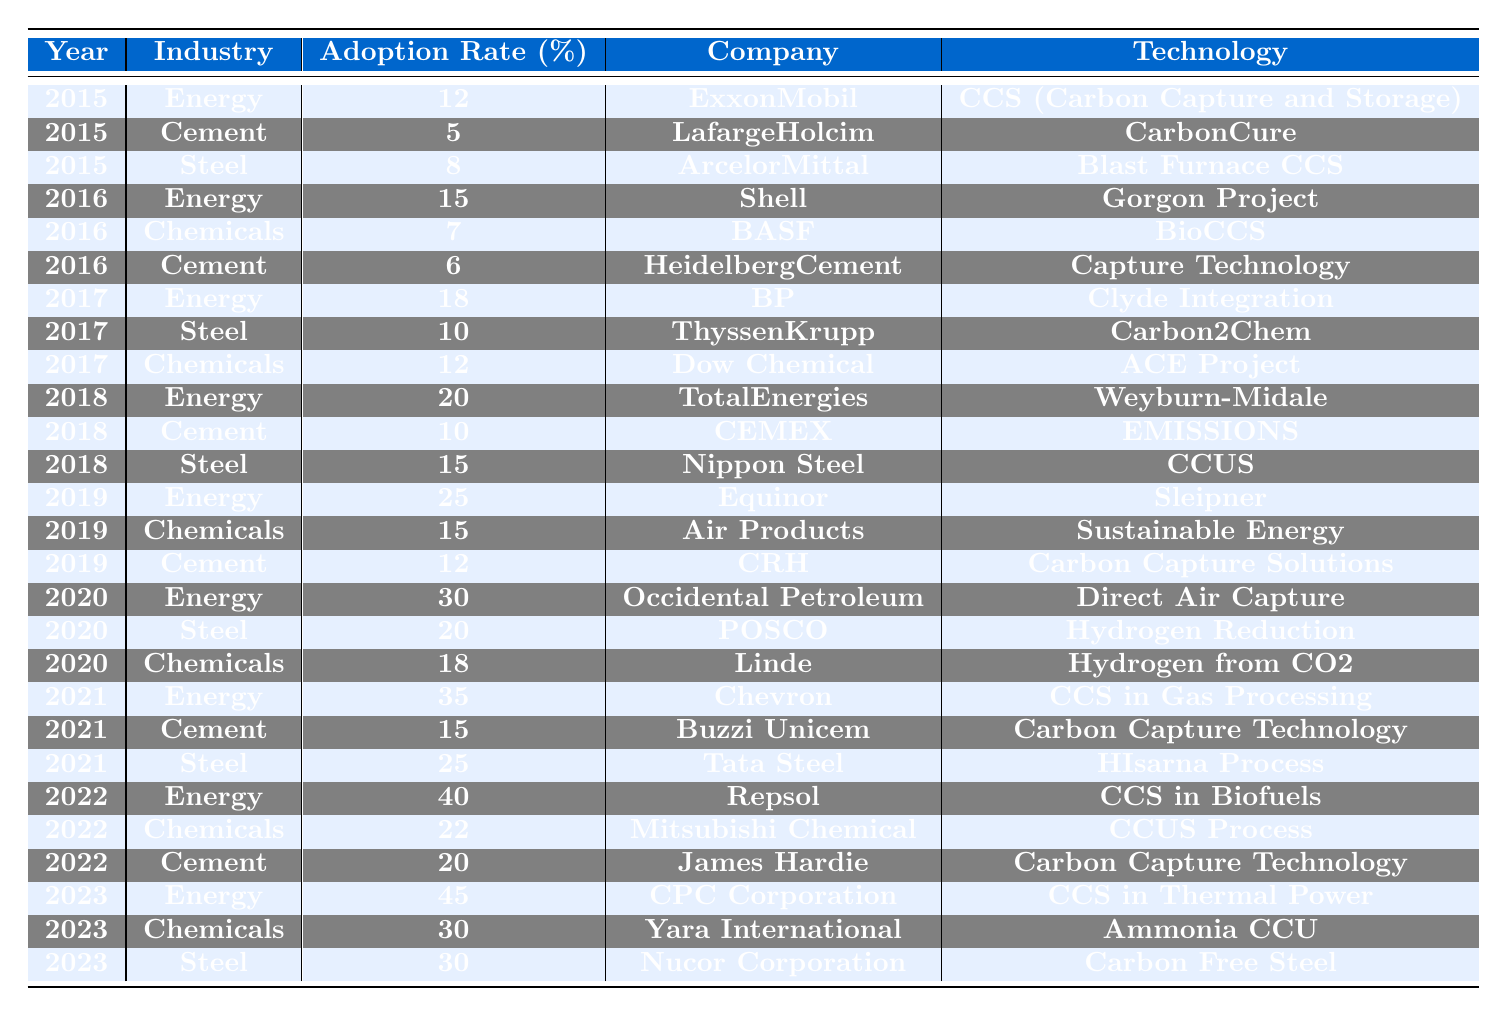What was the highest adoption rate in the Energy industry? The highest adoption rate in the Energy industry is found in 2023 with a rate of 45%.
Answer: 45% Which technology was used by BP in the Energy sector in 2017? BP used the "Clyde Integration" technology in the Energy sector in 2017.
Answer: Clyde Integration What is the difference in adoption rates between Steel in 2015 and in 2023? In 2015, the Steel adoption rate was 8%, while in 2023 it was 30%. The difference is 30% - 8% = 22%.
Answer: 22% Did any Cement companies achieve an adoption rate above 20% in 2022? No, in 2022, the highest adoption rate for Cement companies was 20% by James Hardie.
Answer: No What is the average adoption rate of Carbon capture technology in the Cement industry from 2015 to 2023? The Cement adoption rates from 2015 to 2023 are 5, 6, 10, 12, 15, 20. The sum is 5 + 6 + 10 + 12 + 15 + 20 = 68. There are 6 years, so the average is 68 / 6 = 11.33.
Answer: 11.33 Which Steel company had the lowest adoption rate in 2016? The Steel company with the lowest adoption rate in 2016 is ThyssenKrupp with a rate of 10%.
Answer: ThyssenKrupp Is there a company in the Chemicals industry that achieved an adoption rate of at least 22% in any year? Yes, Mitsubishi Chemical achieved a 22% adoption rate in 2022.
Answer: Yes Which industry showed the most significant increase in adoption rate between 2020 and 2021? For the Energy industry, the adoption rate increased from 30% in 2020 to 35% in 2021, which is an increase of 5%. The Steel industry had a rate increase from 20% in 2020 to 25% in 2021, also an increase of 5%. The Chemicals industry increased from 18% in 2020 to 21%, which is an increase of 3%. Therefore, the Energy and Steel industries both showed the most significant increase of 5%.
Answer: Energy and Steel What was the total adoption rate of Carbon capture technology across all industries in 2019? The adoption rates for 2019 are as follows: Energy (25%), Chemicals (15%), and Cement (12%). Adding those together: 25 + 15 + 12 = 52%.
Answer: 52% Which company in the Chemicals industry had the highest adoption rate in 2023, and what was that rate? Yara International had the highest adoption rate in the Chemicals industry in 2023 with a rate of 30%.
Answer: Yara International, 30% 